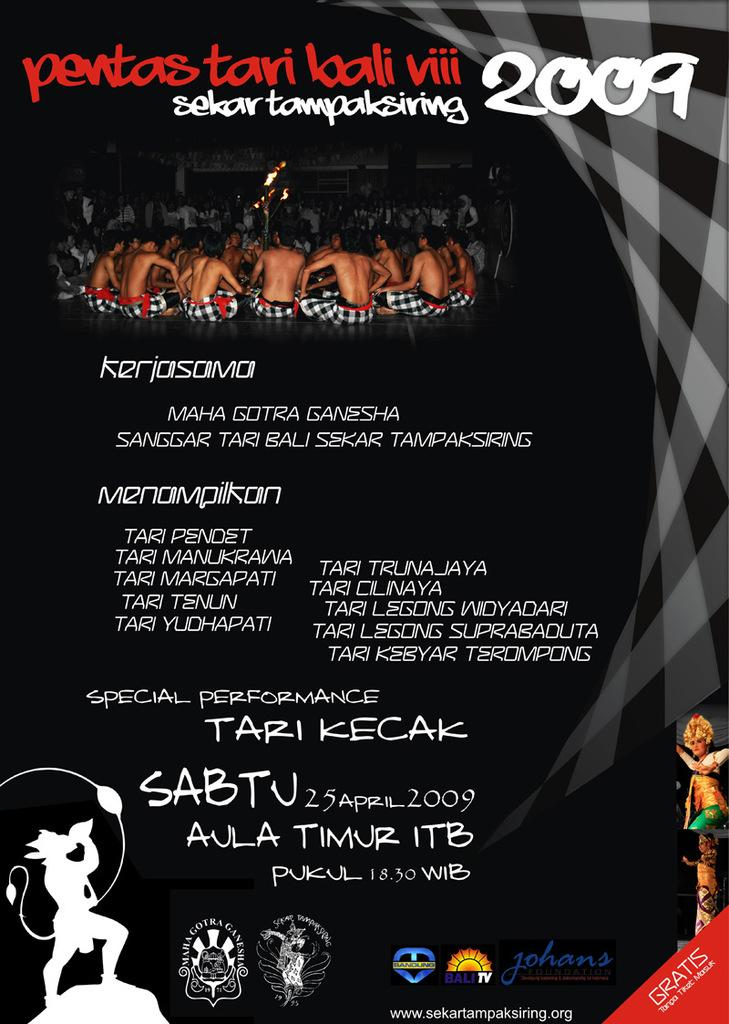<image>
Create a compact narrative representing the image presented. A special performance with the year 2009 is advertised. 